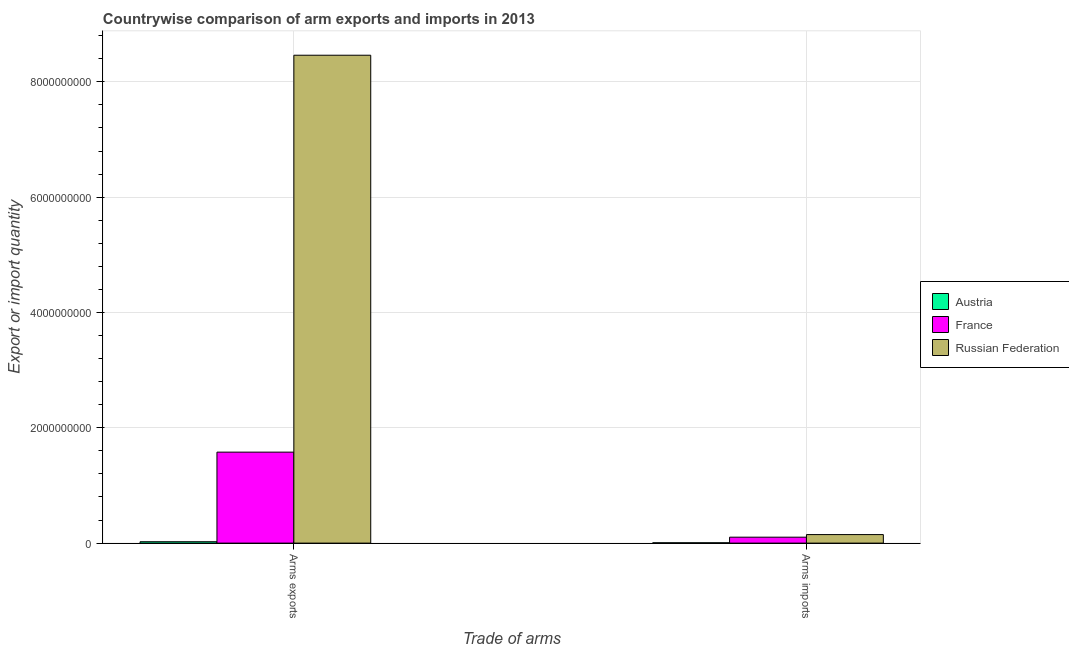How many bars are there on the 2nd tick from the left?
Keep it short and to the point. 3. How many bars are there on the 1st tick from the right?
Give a very brief answer. 3. What is the label of the 2nd group of bars from the left?
Provide a short and direct response. Arms imports. What is the arms imports in Austria?
Give a very brief answer. 6.00e+06. Across all countries, what is the maximum arms exports?
Ensure brevity in your answer.  8.46e+09. Across all countries, what is the minimum arms imports?
Give a very brief answer. 6.00e+06. In which country was the arms exports maximum?
Your response must be concise. Russian Federation. What is the total arms exports in the graph?
Offer a terse response. 1.01e+1. What is the difference between the arms exports in France and that in Austria?
Your response must be concise. 1.55e+09. What is the difference between the arms exports in Austria and the arms imports in France?
Keep it short and to the point. -7.90e+07. What is the average arms imports per country?
Your answer should be compact. 8.57e+07. What is the difference between the arms exports and arms imports in Austria?
Provide a succinct answer. 1.80e+07. In how many countries, is the arms imports greater than 1200000000 ?
Provide a short and direct response. 0. What is the ratio of the arms imports in Austria to that in France?
Offer a very short reply. 0.06. Is the arms imports in Austria less than that in France?
Your answer should be compact. Yes. What does the 3rd bar from the left in Arms imports represents?
Offer a very short reply. Russian Federation. What does the 1st bar from the right in Arms exports represents?
Ensure brevity in your answer.  Russian Federation. How many bars are there?
Your answer should be very brief. 6. Are all the bars in the graph horizontal?
Your answer should be very brief. No. How many countries are there in the graph?
Give a very brief answer. 3. Does the graph contain grids?
Your answer should be very brief. Yes. How are the legend labels stacked?
Your answer should be compact. Vertical. What is the title of the graph?
Your answer should be very brief. Countrywise comparison of arm exports and imports in 2013. Does "Moldova" appear as one of the legend labels in the graph?
Give a very brief answer. No. What is the label or title of the X-axis?
Keep it short and to the point. Trade of arms. What is the label or title of the Y-axis?
Offer a terse response. Export or import quantity. What is the Export or import quantity in Austria in Arms exports?
Give a very brief answer. 2.40e+07. What is the Export or import quantity in France in Arms exports?
Provide a short and direct response. 1.58e+09. What is the Export or import quantity of Russian Federation in Arms exports?
Ensure brevity in your answer.  8.46e+09. What is the Export or import quantity of France in Arms imports?
Your response must be concise. 1.03e+08. What is the Export or import quantity in Russian Federation in Arms imports?
Provide a succinct answer. 1.48e+08. Across all Trade of arms, what is the maximum Export or import quantity in Austria?
Keep it short and to the point. 2.40e+07. Across all Trade of arms, what is the maximum Export or import quantity of France?
Your response must be concise. 1.58e+09. Across all Trade of arms, what is the maximum Export or import quantity in Russian Federation?
Your answer should be very brief. 8.46e+09. Across all Trade of arms, what is the minimum Export or import quantity of Austria?
Your answer should be very brief. 6.00e+06. Across all Trade of arms, what is the minimum Export or import quantity in France?
Keep it short and to the point. 1.03e+08. Across all Trade of arms, what is the minimum Export or import quantity in Russian Federation?
Your answer should be very brief. 1.48e+08. What is the total Export or import quantity of Austria in the graph?
Provide a succinct answer. 3.00e+07. What is the total Export or import quantity in France in the graph?
Make the answer very short. 1.68e+09. What is the total Export or import quantity in Russian Federation in the graph?
Offer a terse response. 8.61e+09. What is the difference between the Export or import quantity in Austria in Arms exports and that in Arms imports?
Your answer should be compact. 1.80e+07. What is the difference between the Export or import quantity of France in Arms exports and that in Arms imports?
Your answer should be very brief. 1.48e+09. What is the difference between the Export or import quantity of Russian Federation in Arms exports and that in Arms imports?
Offer a terse response. 8.31e+09. What is the difference between the Export or import quantity of Austria in Arms exports and the Export or import quantity of France in Arms imports?
Offer a very short reply. -7.90e+07. What is the difference between the Export or import quantity of Austria in Arms exports and the Export or import quantity of Russian Federation in Arms imports?
Your answer should be compact. -1.24e+08. What is the difference between the Export or import quantity in France in Arms exports and the Export or import quantity in Russian Federation in Arms imports?
Make the answer very short. 1.43e+09. What is the average Export or import quantity in Austria per Trade of arms?
Your response must be concise. 1.50e+07. What is the average Export or import quantity in France per Trade of arms?
Provide a short and direct response. 8.40e+08. What is the average Export or import quantity of Russian Federation per Trade of arms?
Your answer should be compact. 4.30e+09. What is the difference between the Export or import quantity in Austria and Export or import quantity in France in Arms exports?
Your answer should be compact. -1.55e+09. What is the difference between the Export or import quantity in Austria and Export or import quantity in Russian Federation in Arms exports?
Your response must be concise. -8.44e+09. What is the difference between the Export or import quantity in France and Export or import quantity in Russian Federation in Arms exports?
Make the answer very short. -6.88e+09. What is the difference between the Export or import quantity of Austria and Export or import quantity of France in Arms imports?
Keep it short and to the point. -9.70e+07. What is the difference between the Export or import quantity in Austria and Export or import quantity in Russian Federation in Arms imports?
Provide a short and direct response. -1.42e+08. What is the difference between the Export or import quantity in France and Export or import quantity in Russian Federation in Arms imports?
Make the answer very short. -4.50e+07. What is the ratio of the Export or import quantity in Austria in Arms exports to that in Arms imports?
Make the answer very short. 4. What is the ratio of the Export or import quantity of France in Arms exports to that in Arms imports?
Give a very brief answer. 15.32. What is the ratio of the Export or import quantity of Russian Federation in Arms exports to that in Arms imports?
Your answer should be compact. 57.18. What is the difference between the highest and the second highest Export or import quantity in Austria?
Your response must be concise. 1.80e+07. What is the difference between the highest and the second highest Export or import quantity of France?
Provide a short and direct response. 1.48e+09. What is the difference between the highest and the second highest Export or import quantity of Russian Federation?
Provide a succinct answer. 8.31e+09. What is the difference between the highest and the lowest Export or import quantity of Austria?
Your answer should be very brief. 1.80e+07. What is the difference between the highest and the lowest Export or import quantity of France?
Ensure brevity in your answer.  1.48e+09. What is the difference between the highest and the lowest Export or import quantity of Russian Federation?
Your answer should be compact. 8.31e+09. 